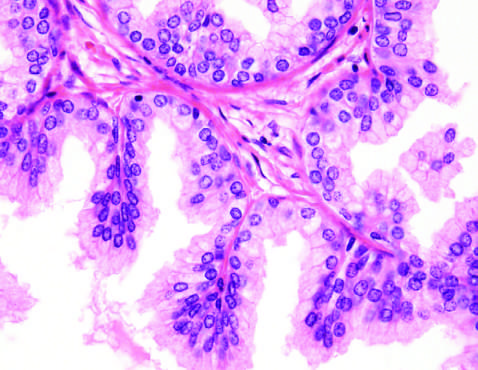does four-chamber dilation and hypertrophy demonstrate a well-demarcated nodule at the right of the field, with a portion of urethra seen to the left?
Answer the question using a single word or phrase. No 